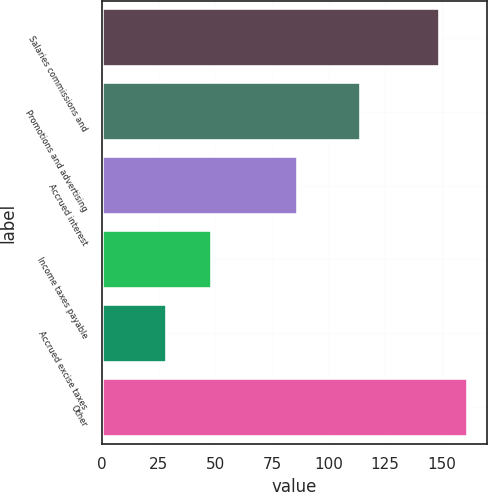<chart> <loc_0><loc_0><loc_500><loc_500><bar_chart><fcel>Salaries commissions and<fcel>Promotions and advertising<fcel>Accrued interest<fcel>Income taxes payable<fcel>Accrued excise taxes<fcel>Other<nl><fcel>149<fcel>114.1<fcel>86.7<fcel>48.5<fcel>28.7<fcel>161.77<nl></chart> 